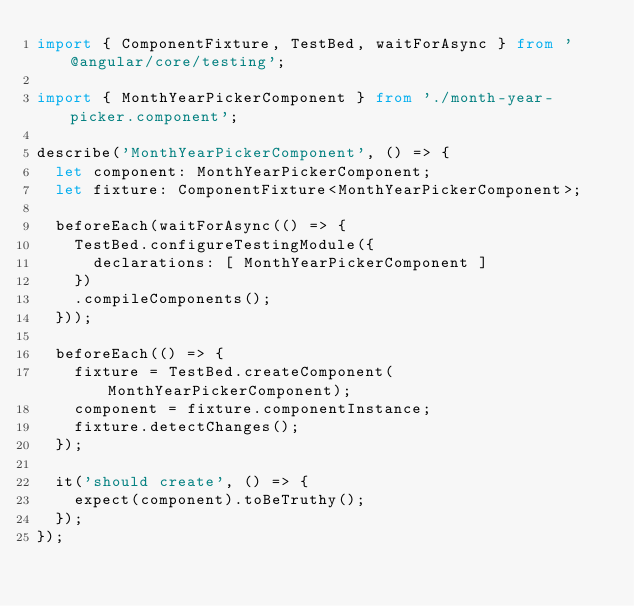Convert code to text. <code><loc_0><loc_0><loc_500><loc_500><_TypeScript_>import { ComponentFixture, TestBed, waitForAsync } from '@angular/core/testing';

import { MonthYearPickerComponent } from './month-year-picker.component';

describe('MonthYearPickerComponent', () => {
  let component: MonthYearPickerComponent;
  let fixture: ComponentFixture<MonthYearPickerComponent>;

  beforeEach(waitForAsync(() => {
    TestBed.configureTestingModule({
      declarations: [ MonthYearPickerComponent ]
    })
    .compileComponents();
  }));

  beforeEach(() => {
    fixture = TestBed.createComponent(MonthYearPickerComponent);
    component = fixture.componentInstance;
    fixture.detectChanges();
  });

  it('should create', () => {
    expect(component).toBeTruthy();
  });
});
</code> 